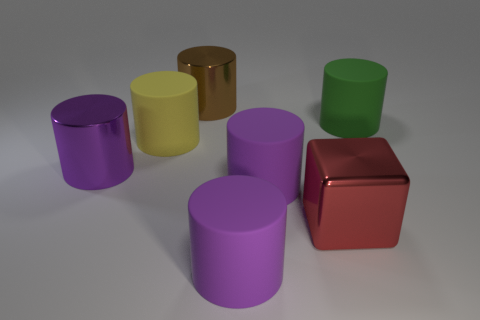How many objects are there in the image? There are seven objects in the image.  Can you describe the colors of these objects? Certainly, in the image we see objects in various colors: purple, yellow, brown, green, and red. 